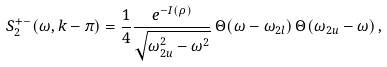Convert formula to latex. <formula><loc_0><loc_0><loc_500><loc_500>S _ { 2 } ^ { + - } ( \omega , k - \pi ) = \frac { 1 } { 4 } \frac { e ^ { - I ( \rho ) } } { \sqrt { \omega _ { 2 u } ^ { 2 } - \omega ^ { 2 } } } \, \Theta ( \omega - \omega _ { 2 l } ) \, \Theta ( \omega _ { 2 u } - \omega ) \, ,</formula> 